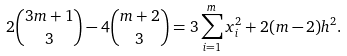<formula> <loc_0><loc_0><loc_500><loc_500>2 \binom { 3 m + 1 } { 3 } - 4 \binom { m + 2 } { 3 } = 3 \sum _ { i = 1 } ^ { m } x _ { i } ^ { 2 } + 2 ( m - 2 ) h ^ { 2 } .</formula> 